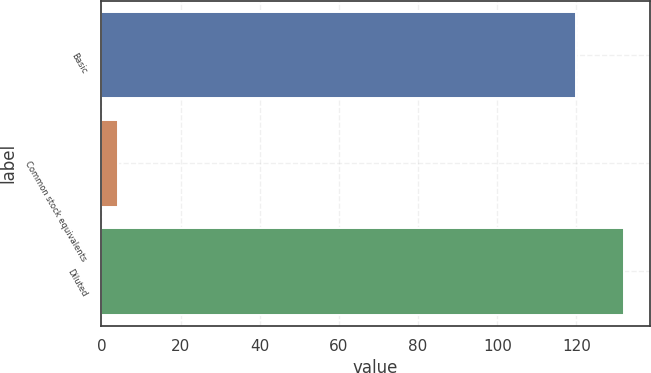Convert chart to OTSL. <chart><loc_0><loc_0><loc_500><loc_500><bar_chart><fcel>Basic<fcel>Common stock equivalents<fcel>Diluted<nl><fcel>119.9<fcel>4.1<fcel>131.89<nl></chart> 